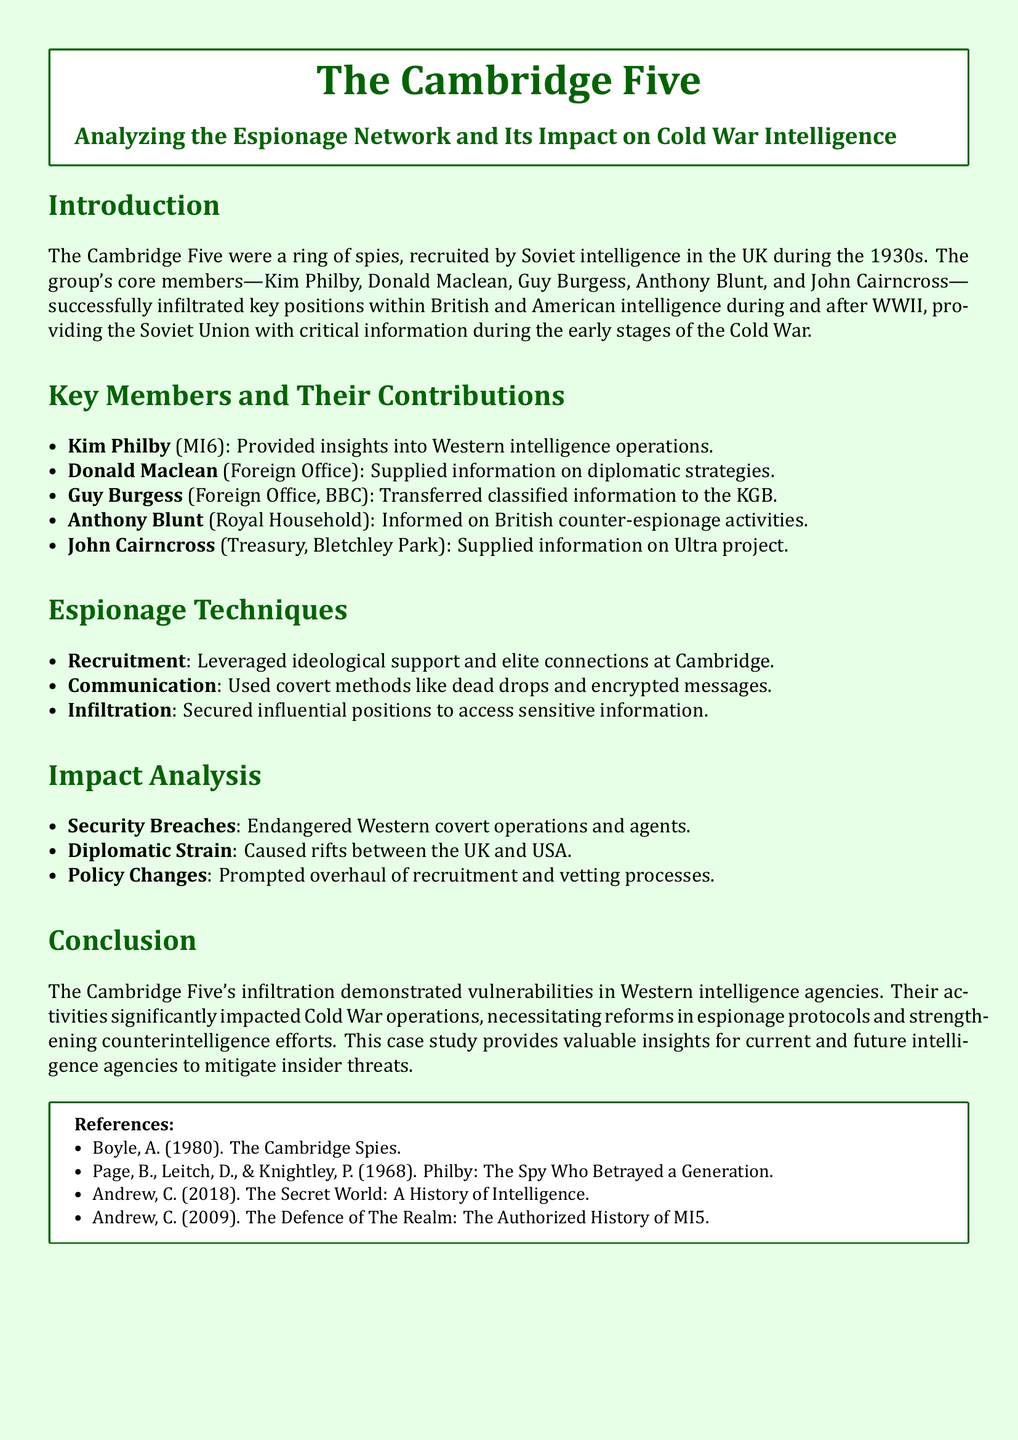What were the names of the Cambridge Five? The Cambridge Five consisted of Kim Philby, Donald Maclean, Guy Burgess, Anthony Blunt, and John Cairncross.
Answer: Kim Philby, Donald Maclean, Guy Burgess, Anthony Blunt, John Cairncross Who was recruited from MI6? Kim Philby was associated with MI6 and provided insights into Western intelligence operations.
Answer: Kim Philby What position did John Cairncross hold? John Cairncross worked at the Treasury and Bletchley Park, supplying information on the Ultra project.
Answer: Treasury, Bletchley Park Which technique involved using covert communication methods? The Cambridge Five employed techniques such as dead drops and encrypted messages for communication.
Answer: Communication What impact did the Cambridge Five have on Western intelligence? Their infiltration led to significant security breaches, endangering covert operations and agents.
Answer: Security Breaches What prompted changes in espionage protocols in the UK and USA? The activities of the Cambridge Five necessitated reforms in recruitment and vetting processes.
Answer: Policy Changes What was one of the main motivations for recruitment into the Cambridge Five? Ideological support and elite connections at Cambridge were key motivations for recruitment.
Answer: Ideological support What document type is this case study? This document is a case study analyzing an espionage network and its historical impact.
Answer: Case study 